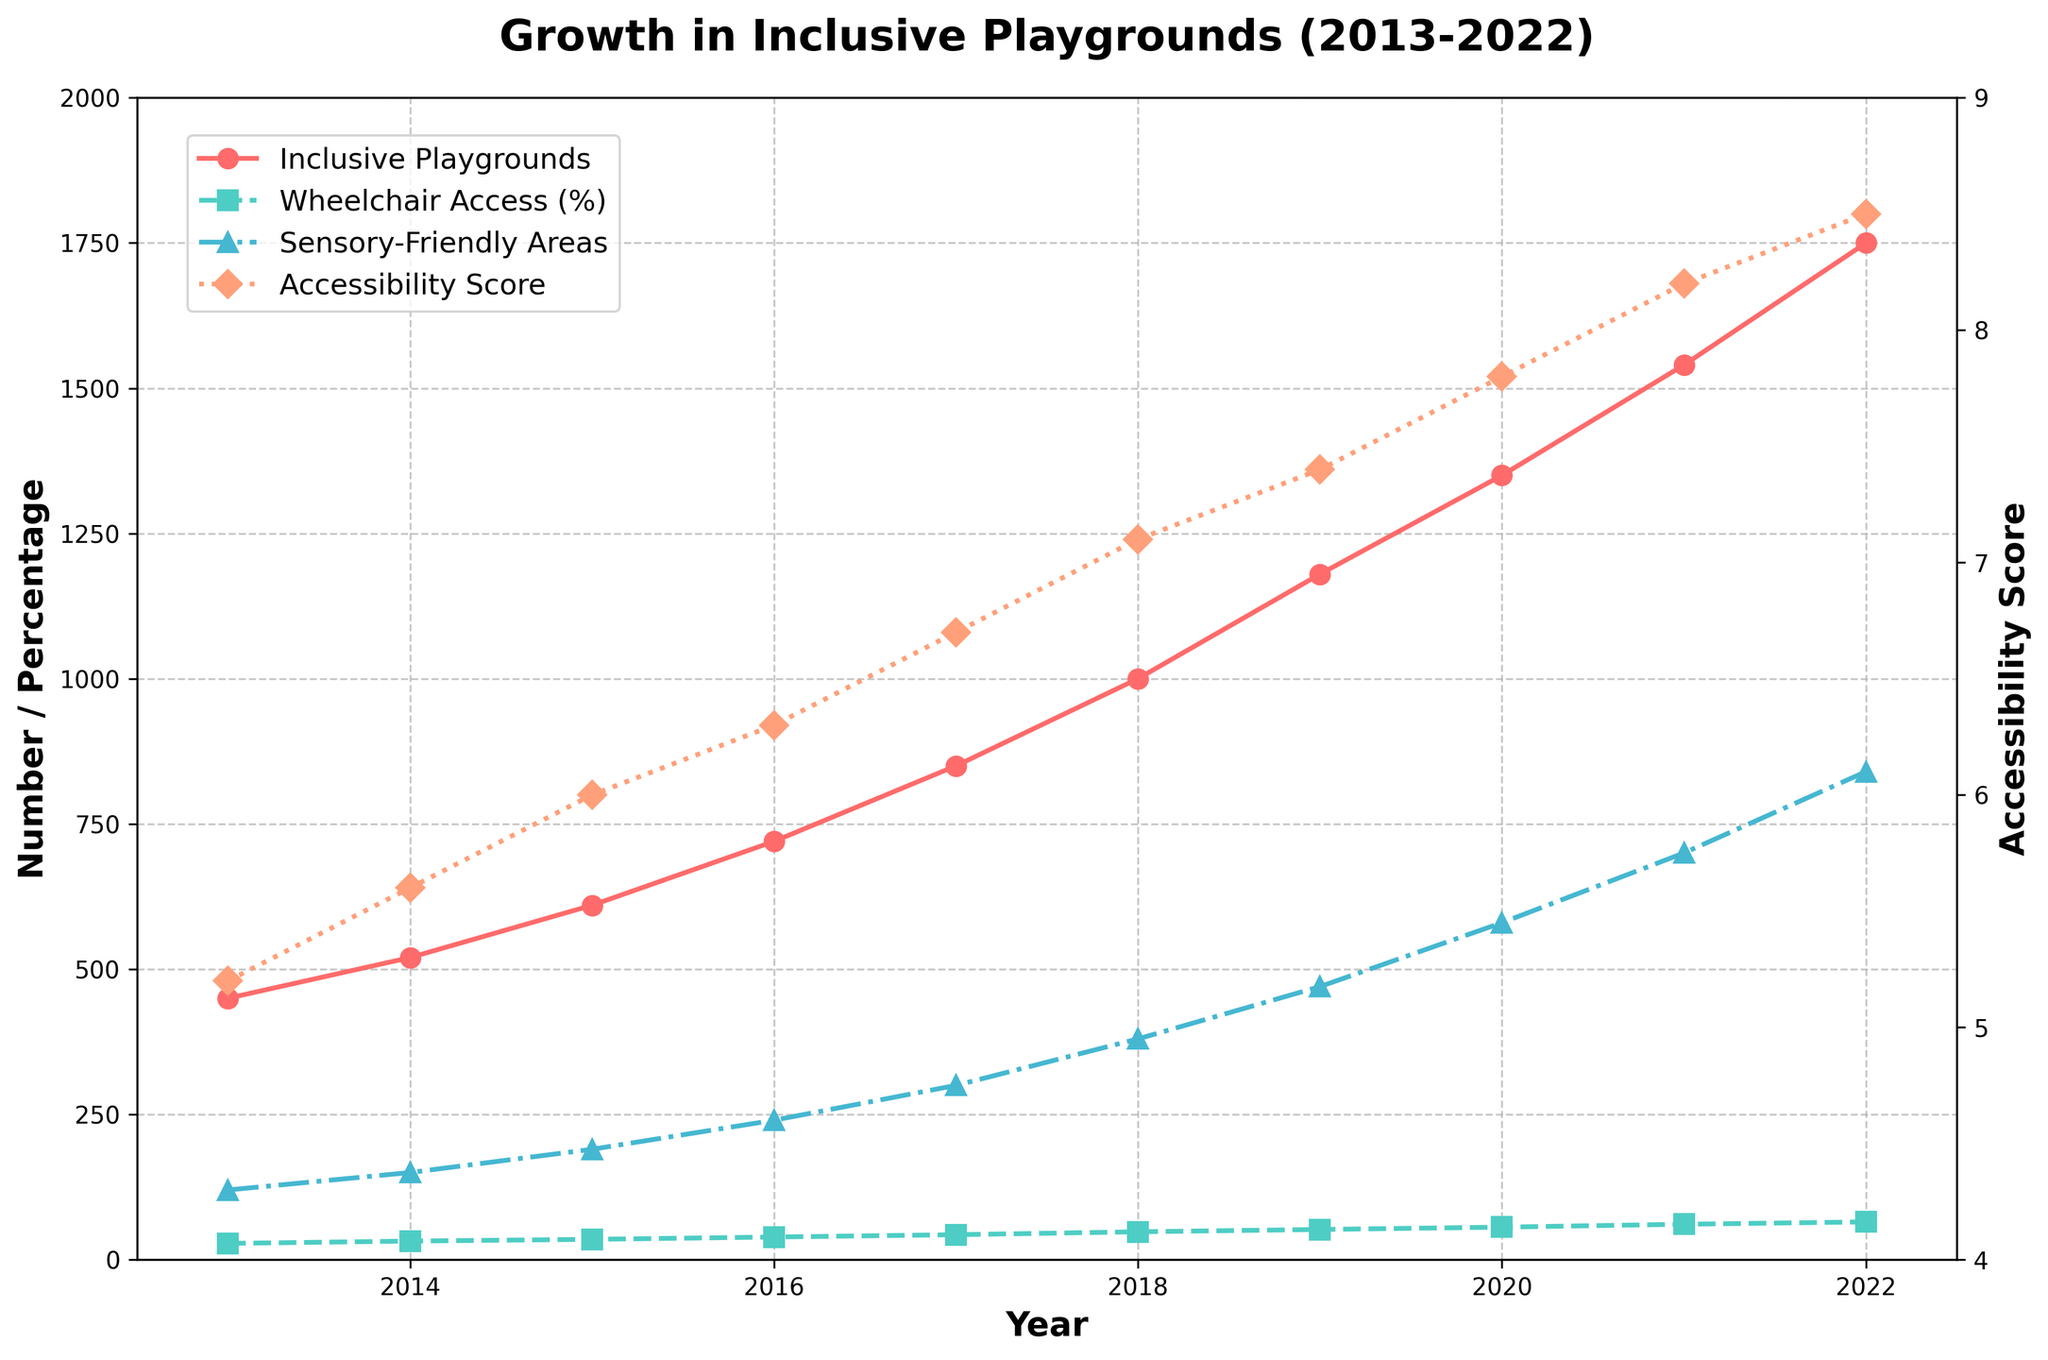What is the trend in the number of inclusive playgrounds from 2013 to 2022? The line representing the number of inclusive playgrounds shows a clear upward trend from 450 in 2013 to 1750 in 2022.
Answer: Upward trend Which year saw the highest percentage of playgrounds with wheelchair access? The line representing the percentage of playgrounds with wheelchair access peaks in 2022, with a value of 65%.
Answer: 2022 Compare the number of sensory-friendly play areas in 2015 and 2020. Which year had more? In 2015, there are 190 sensory-friendly play areas, while in 2020, there are 580.
Answer: 2020 How does the accessibility score trend compare to the trend in the number of inclusive playgrounds? Both the accessibility score and the number of inclusive playgrounds show an increasing trend from 2013 to 2022, but the accessibility score rises more linearly while the number of inclusive playgrounds sees a steeper increase.
Answer: Both are increasing, with the accessibility score rising linearly and inclusive playgrounds steeply What was the average accessibility score in the first three years (2013-2015) compared to the last three years (2020-2022)? Average accessibility score for 2013-2015 = (5.2 + 5.6 + 6.0) / 3 = 5.6; for 2020-2022 = (7.8 + 8.2 + 8.5) / 3 = 8.17
Answer: First: 5.6, Last: 8.17 By how much did the number of sensory-friendly play areas increase from 2013 to 2022? The number of sensory-friendly play areas increased from 120 in 2013 to 840 in 2022. The increase is 840 - 120 = 720.
Answer: 720 Given the data, which aspect (number of inclusive playgrounds, wheelchair access percentage, sensory-friendly play areas, or accessibility score) showed the greatest increase from 2013 to 2022? The number of inclusive playgrounds increased from 450 in 2013 to 1750 in 2022 which is an increase of 1300, which is the highest among all the given aspects.
Answer: Number of inclusive playgrounds What was the growth rate of the average accessibility score from 2013 to 2022? The average accessibility score grew from 5.2 in 2013 to 8.5 in 2022. The growth rate is ((8.5 - 5.2) / 5.2) * 100 ≈ 63.46%.
Answer: 63.46% In which year did the number of inclusive playgrounds reach 1000? The line representing the number of inclusive playgrounds hits 1000 in the year 2018.
Answer: 2018 How did the number of inclusive playgrounds change between 2016 and 2019, and what is the average yearly increase over this period? The number of inclusive playgrounds increased from 720 in 2016 to 1180 in 2019, a change of 460 over 3 years, so the average yearly increase is 460 / 3 ≈ 153.33.
Answer: 153.33 